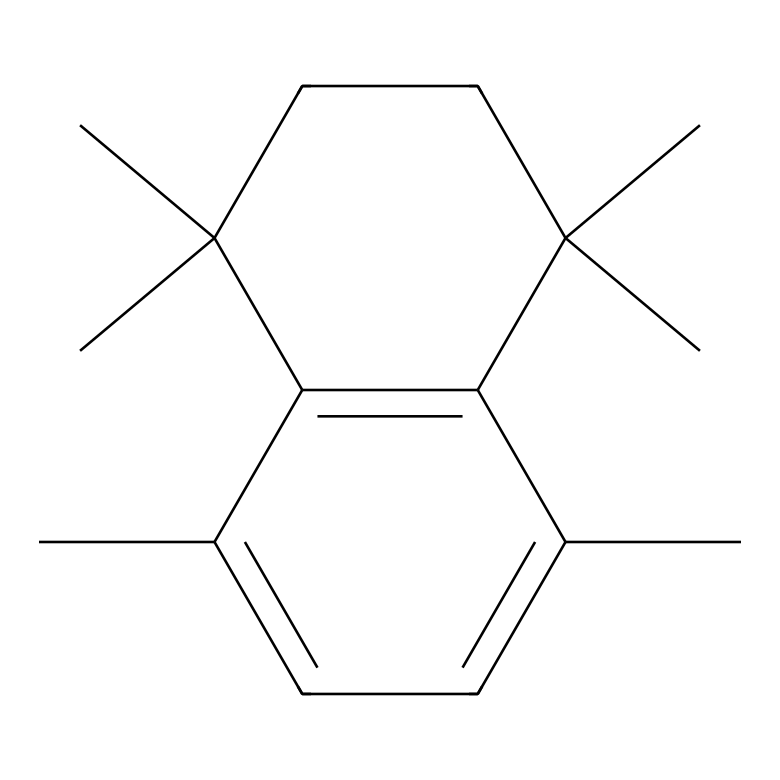How many carbon atoms are in this chemical structure? By analyzing the SMILES representation, we can count the number of carbon atoms present in the structure. Each 'C' indicates a carbon atom, and by collectively counting them from the structure, we find a total of 20 carbon atoms.
Answer: 20 What is the primary type of bonds present in this hydrocarbon? In hydrocarbons, carbon atoms are primarily connected to each other by single or double bonds. Observing the structure, we see that it mostly consists of single bonds along with some double bonds (indicated by '=' in the SMILES), making carbon-carbon single bonds the primary type.
Answer: single bonds What is the molecular formula inferred from the SMILES structure? To deduce the molecular formula from the SMILES code, we can count the carbon (C) and hydrogen (H) atoms. For every carbon atom, typically two more hydrogen atoms are bonded (except for double bonds which reduce H's). Counting leads us to a molecular formula of C20H34.
Answer: C20H34 How many rings are present in the structure? Upon examining the chemical structure, we can identify the presence of two cyclic components (rings) in the SMILES. The notation 'CC1=CC' suggests a cycle starting from 'C1' and closing loops back to the initial carbon. Thus, there are two rings in this structure.
Answer: 2 What type of hydrocarbon is represented in this chemical structure? Given the structure is fully composed of carbon and hydrogen with no functional groups involving other elements, it classifies as a polycyclic hydrocarbon, typical for natural pitch formation in preservation contexts.
Answer: polycyclic hydrocarbon Does this hydrocarbon structure contain any double bonds? By examining the SMILES representation, we can spot instances of '=' indicating double bonds in the carbon skeleton. This means that the structure does indeed contain double bonds between some carbons.
Answer: yes 